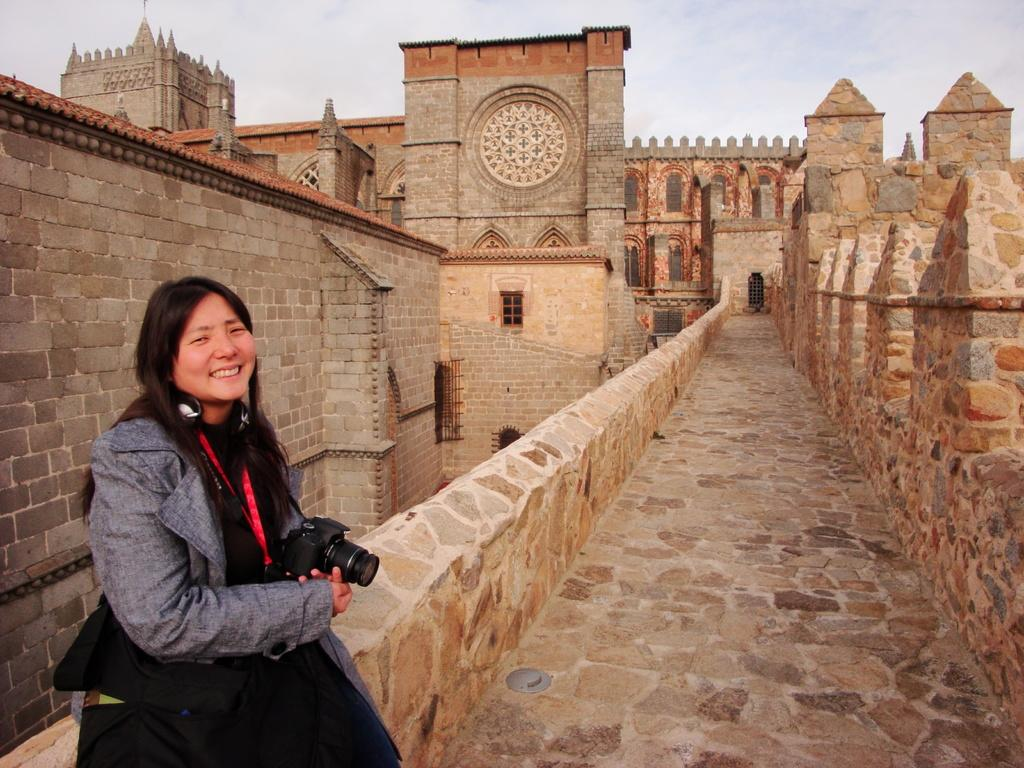Where was the image taken? The image was taken in a fort. What can be seen on the left side of the image? There is a wall made of bricks on the left side of the image. Who is present in the image? There is a woman sitting in the image. What is the woman wearing? The woman is wearing a gray jacket. What is the woman holding in the image? The woman is holding a camera. What type of tax is being discussed in the image? There is no discussion of tax in the image; it features a woman sitting in a fort holding a camera. How many doors can be seen in the image? There are no doors visible in the image; it shows a woman sitting in a fort with a brick wall on the left side. 